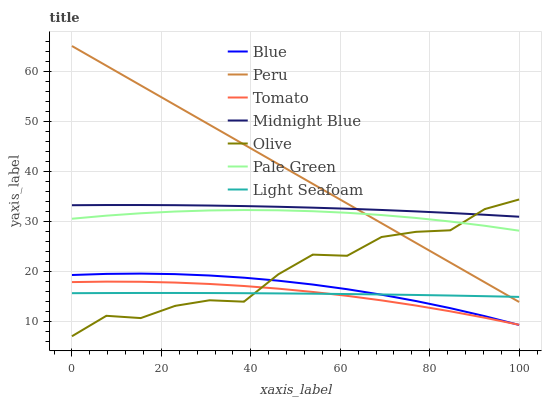Does Midnight Blue have the minimum area under the curve?
Answer yes or no. No. Does Midnight Blue have the maximum area under the curve?
Answer yes or no. No. Is Tomato the smoothest?
Answer yes or no. No. Is Tomato the roughest?
Answer yes or no. No. Does Tomato have the lowest value?
Answer yes or no. No. Does Tomato have the highest value?
Answer yes or no. No. Is Light Seafoam less than Pale Green?
Answer yes or no. Yes. Is Pale Green greater than Tomato?
Answer yes or no. Yes. Does Light Seafoam intersect Pale Green?
Answer yes or no. No. 